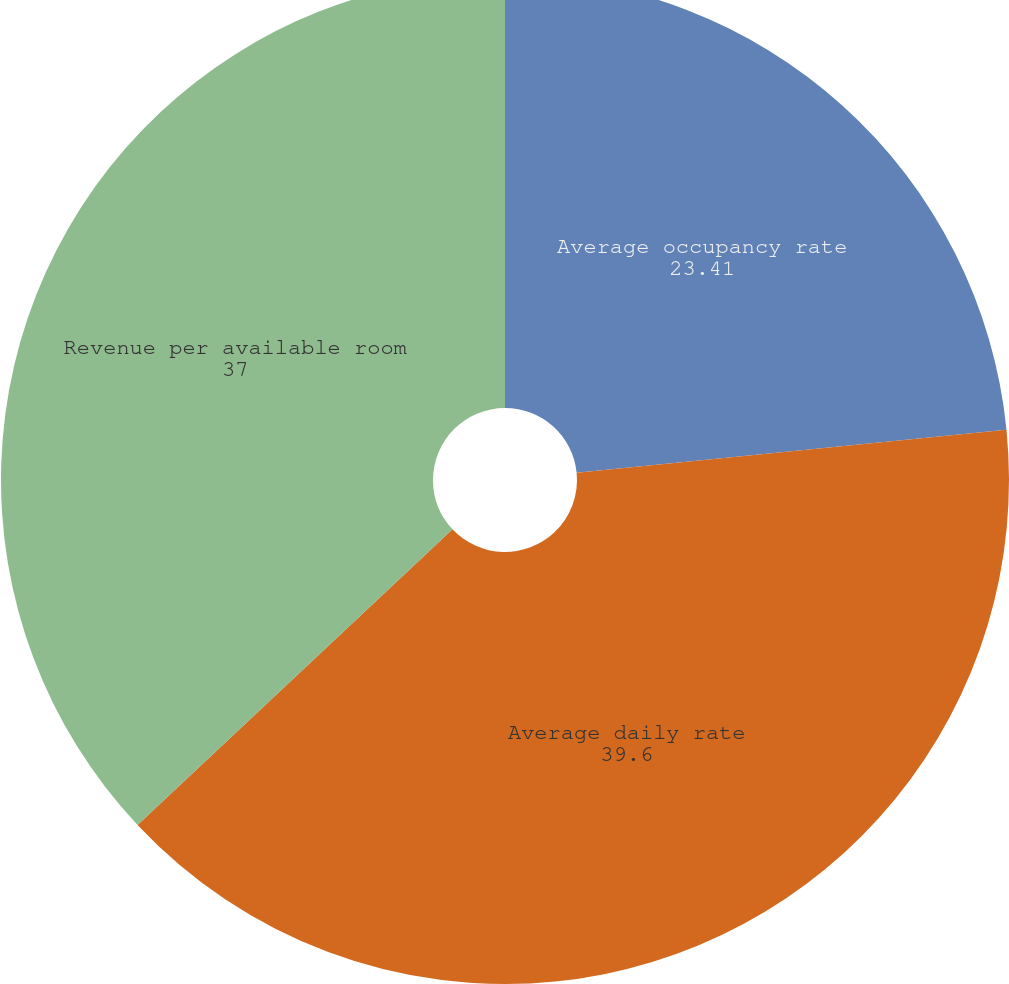Convert chart to OTSL. <chart><loc_0><loc_0><loc_500><loc_500><pie_chart><fcel>Average occupancy rate<fcel>Average daily rate<fcel>Revenue per available room<nl><fcel>23.41%<fcel>39.6%<fcel>37.0%<nl></chart> 